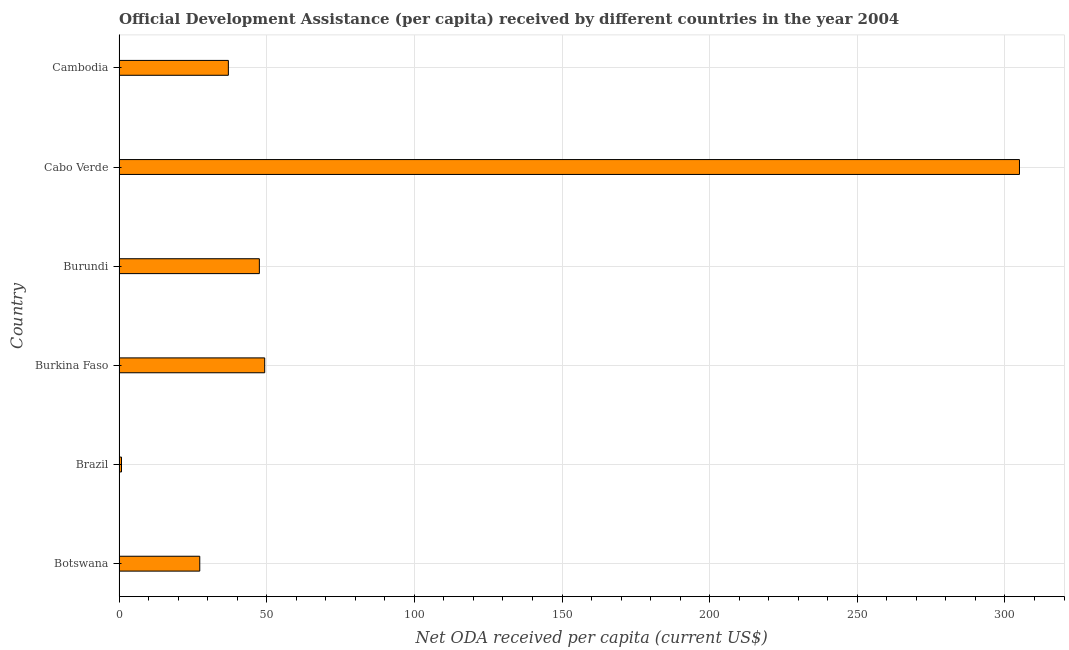Does the graph contain grids?
Keep it short and to the point. Yes. What is the title of the graph?
Make the answer very short. Official Development Assistance (per capita) received by different countries in the year 2004. What is the label or title of the X-axis?
Keep it short and to the point. Net ODA received per capita (current US$). What is the label or title of the Y-axis?
Your response must be concise. Country. What is the net oda received per capita in Cambodia?
Offer a terse response. 37.02. Across all countries, what is the maximum net oda received per capita?
Your response must be concise. 304.91. Across all countries, what is the minimum net oda received per capita?
Keep it short and to the point. 0.83. In which country was the net oda received per capita maximum?
Your response must be concise. Cabo Verde. What is the sum of the net oda received per capita?
Offer a terse response. 466.93. What is the difference between the net oda received per capita in Botswana and Burundi?
Offer a terse response. -20.18. What is the average net oda received per capita per country?
Offer a terse response. 77.82. What is the median net oda received per capita?
Offer a very short reply. 42.27. In how many countries, is the net oda received per capita greater than 300 US$?
Keep it short and to the point. 1. What is the ratio of the net oda received per capita in Burkina Faso to that in Cambodia?
Provide a short and direct response. 1.33. Is the net oda received per capita in Burundi less than that in Cabo Verde?
Give a very brief answer. Yes. What is the difference between the highest and the second highest net oda received per capita?
Ensure brevity in your answer.  255.59. What is the difference between the highest and the lowest net oda received per capita?
Offer a terse response. 304.08. In how many countries, is the net oda received per capita greater than the average net oda received per capita taken over all countries?
Offer a very short reply. 1. How many bars are there?
Make the answer very short. 6. What is the difference between two consecutive major ticks on the X-axis?
Provide a succinct answer. 50. Are the values on the major ticks of X-axis written in scientific E-notation?
Ensure brevity in your answer.  No. What is the Net ODA received per capita (current US$) in Botswana?
Your answer should be compact. 27.33. What is the Net ODA received per capita (current US$) of Brazil?
Provide a short and direct response. 0.83. What is the Net ODA received per capita (current US$) in Burkina Faso?
Offer a terse response. 49.32. What is the Net ODA received per capita (current US$) of Burundi?
Your response must be concise. 47.51. What is the Net ODA received per capita (current US$) of Cabo Verde?
Offer a very short reply. 304.91. What is the Net ODA received per capita (current US$) in Cambodia?
Give a very brief answer. 37.02. What is the difference between the Net ODA received per capita (current US$) in Botswana and Brazil?
Your answer should be compact. 26.51. What is the difference between the Net ODA received per capita (current US$) in Botswana and Burkina Faso?
Offer a very short reply. -21.99. What is the difference between the Net ODA received per capita (current US$) in Botswana and Burundi?
Offer a terse response. -20.18. What is the difference between the Net ODA received per capita (current US$) in Botswana and Cabo Verde?
Ensure brevity in your answer.  -277.58. What is the difference between the Net ODA received per capita (current US$) in Botswana and Cambodia?
Ensure brevity in your answer.  -9.68. What is the difference between the Net ODA received per capita (current US$) in Brazil and Burkina Faso?
Offer a very short reply. -48.49. What is the difference between the Net ODA received per capita (current US$) in Brazil and Burundi?
Make the answer very short. -46.69. What is the difference between the Net ODA received per capita (current US$) in Brazil and Cabo Verde?
Offer a very short reply. -304.08. What is the difference between the Net ODA received per capita (current US$) in Brazil and Cambodia?
Offer a very short reply. -36.19. What is the difference between the Net ODA received per capita (current US$) in Burkina Faso and Burundi?
Your answer should be very brief. 1.81. What is the difference between the Net ODA received per capita (current US$) in Burkina Faso and Cabo Verde?
Keep it short and to the point. -255.59. What is the difference between the Net ODA received per capita (current US$) in Burkina Faso and Cambodia?
Offer a terse response. 12.31. What is the difference between the Net ODA received per capita (current US$) in Burundi and Cabo Verde?
Provide a short and direct response. -257.4. What is the difference between the Net ODA received per capita (current US$) in Burundi and Cambodia?
Your answer should be compact. 10.5. What is the difference between the Net ODA received per capita (current US$) in Cabo Verde and Cambodia?
Keep it short and to the point. 267.9. What is the ratio of the Net ODA received per capita (current US$) in Botswana to that in Brazil?
Provide a succinct answer. 32.95. What is the ratio of the Net ODA received per capita (current US$) in Botswana to that in Burkina Faso?
Make the answer very short. 0.55. What is the ratio of the Net ODA received per capita (current US$) in Botswana to that in Burundi?
Your answer should be very brief. 0.57. What is the ratio of the Net ODA received per capita (current US$) in Botswana to that in Cabo Verde?
Provide a short and direct response. 0.09. What is the ratio of the Net ODA received per capita (current US$) in Botswana to that in Cambodia?
Offer a very short reply. 0.74. What is the ratio of the Net ODA received per capita (current US$) in Brazil to that in Burkina Faso?
Provide a succinct answer. 0.02. What is the ratio of the Net ODA received per capita (current US$) in Brazil to that in Burundi?
Offer a very short reply. 0.02. What is the ratio of the Net ODA received per capita (current US$) in Brazil to that in Cabo Verde?
Offer a very short reply. 0. What is the ratio of the Net ODA received per capita (current US$) in Brazil to that in Cambodia?
Make the answer very short. 0.02. What is the ratio of the Net ODA received per capita (current US$) in Burkina Faso to that in Burundi?
Your response must be concise. 1.04. What is the ratio of the Net ODA received per capita (current US$) in Burkina Faso to that in Cabo Verde?
Your response must be concise. 0.16. What is the ratio of the Net ODA received per capita (current US$) in Burkina Faso to that in Cambodia?
Provide a short and direct response. 1.33. What is the ratio of the Net ODA received per capita (current US$) in Burundi to that in Cabo Verde?
Keep it short and to the point. 0.16. What is the ratio of the Net ODA received per capita (current US$) in Burundi to that in Cambodia?
Offer a terse response. 1.28. What is the ratio of the Net ODA received per capita (current US$) in Cabo Verde to that in Cambodia?
Keep it short and to the point. 8.24. 